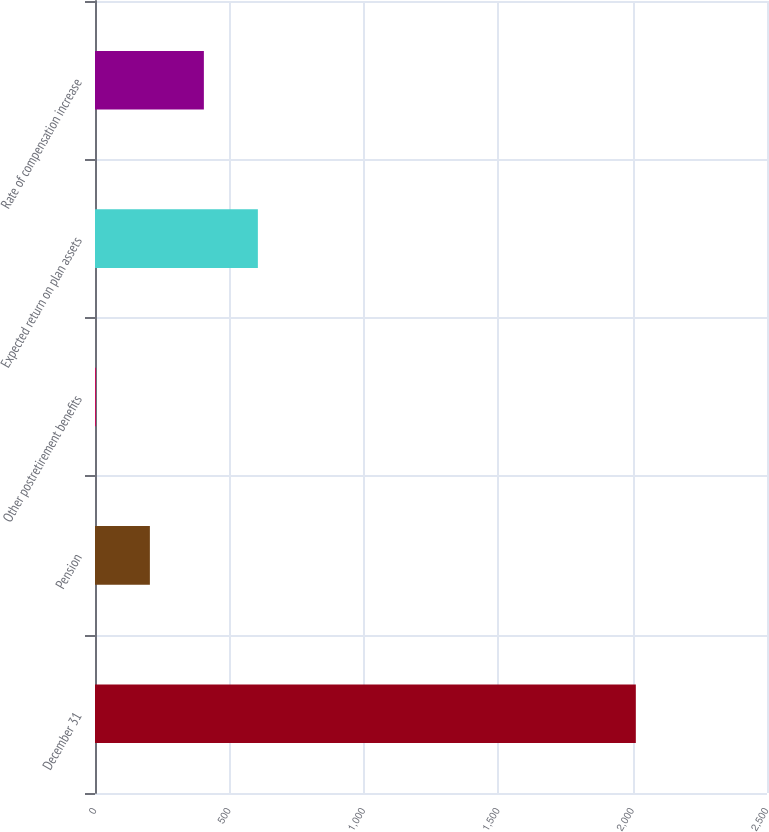<chart> <loc_0><loc_0><loc_500><loc_500><bar_chart><fcel>December 31<fcel>Pension<fcel>Other postretirement benefits<fcel>Expected return on plan assets<fcel>Rate of compensation increase<nl><fcel>2012<fcel>204.17<fcel>3.3<fcel>605.91<fcel>405.04<nl></chart> 